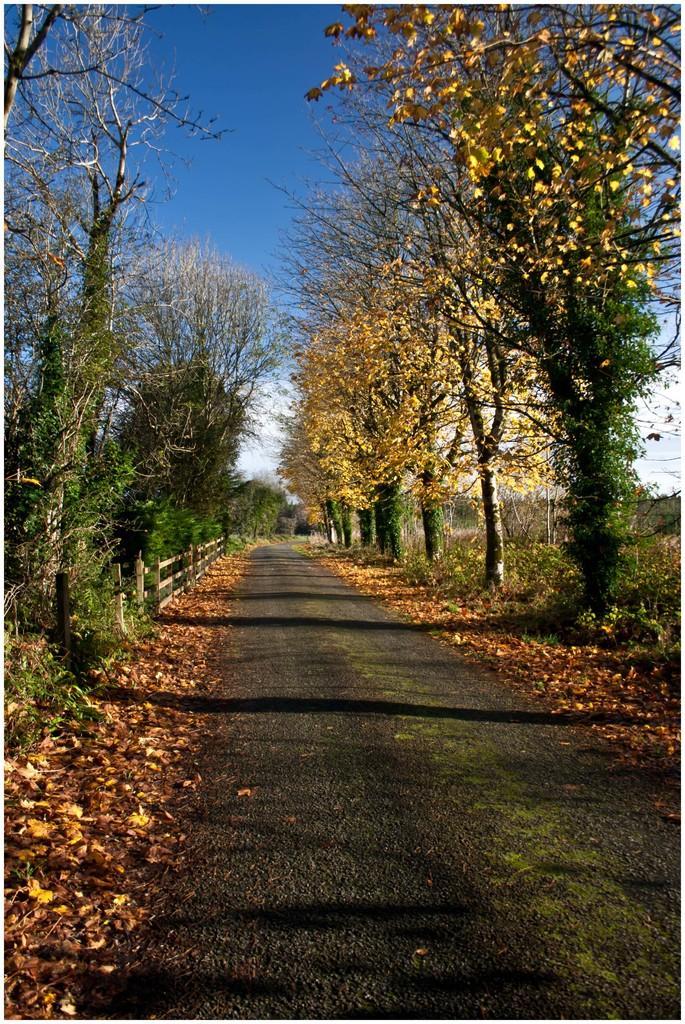Can you describe this image briefly? In front of the image there is a road, besides the road there are dry leaves, on the right side of the road there are trees, on the left side of the road there is a wooden fence, behind the fence there are trees, at the top of the image there are clouds in the sky. 